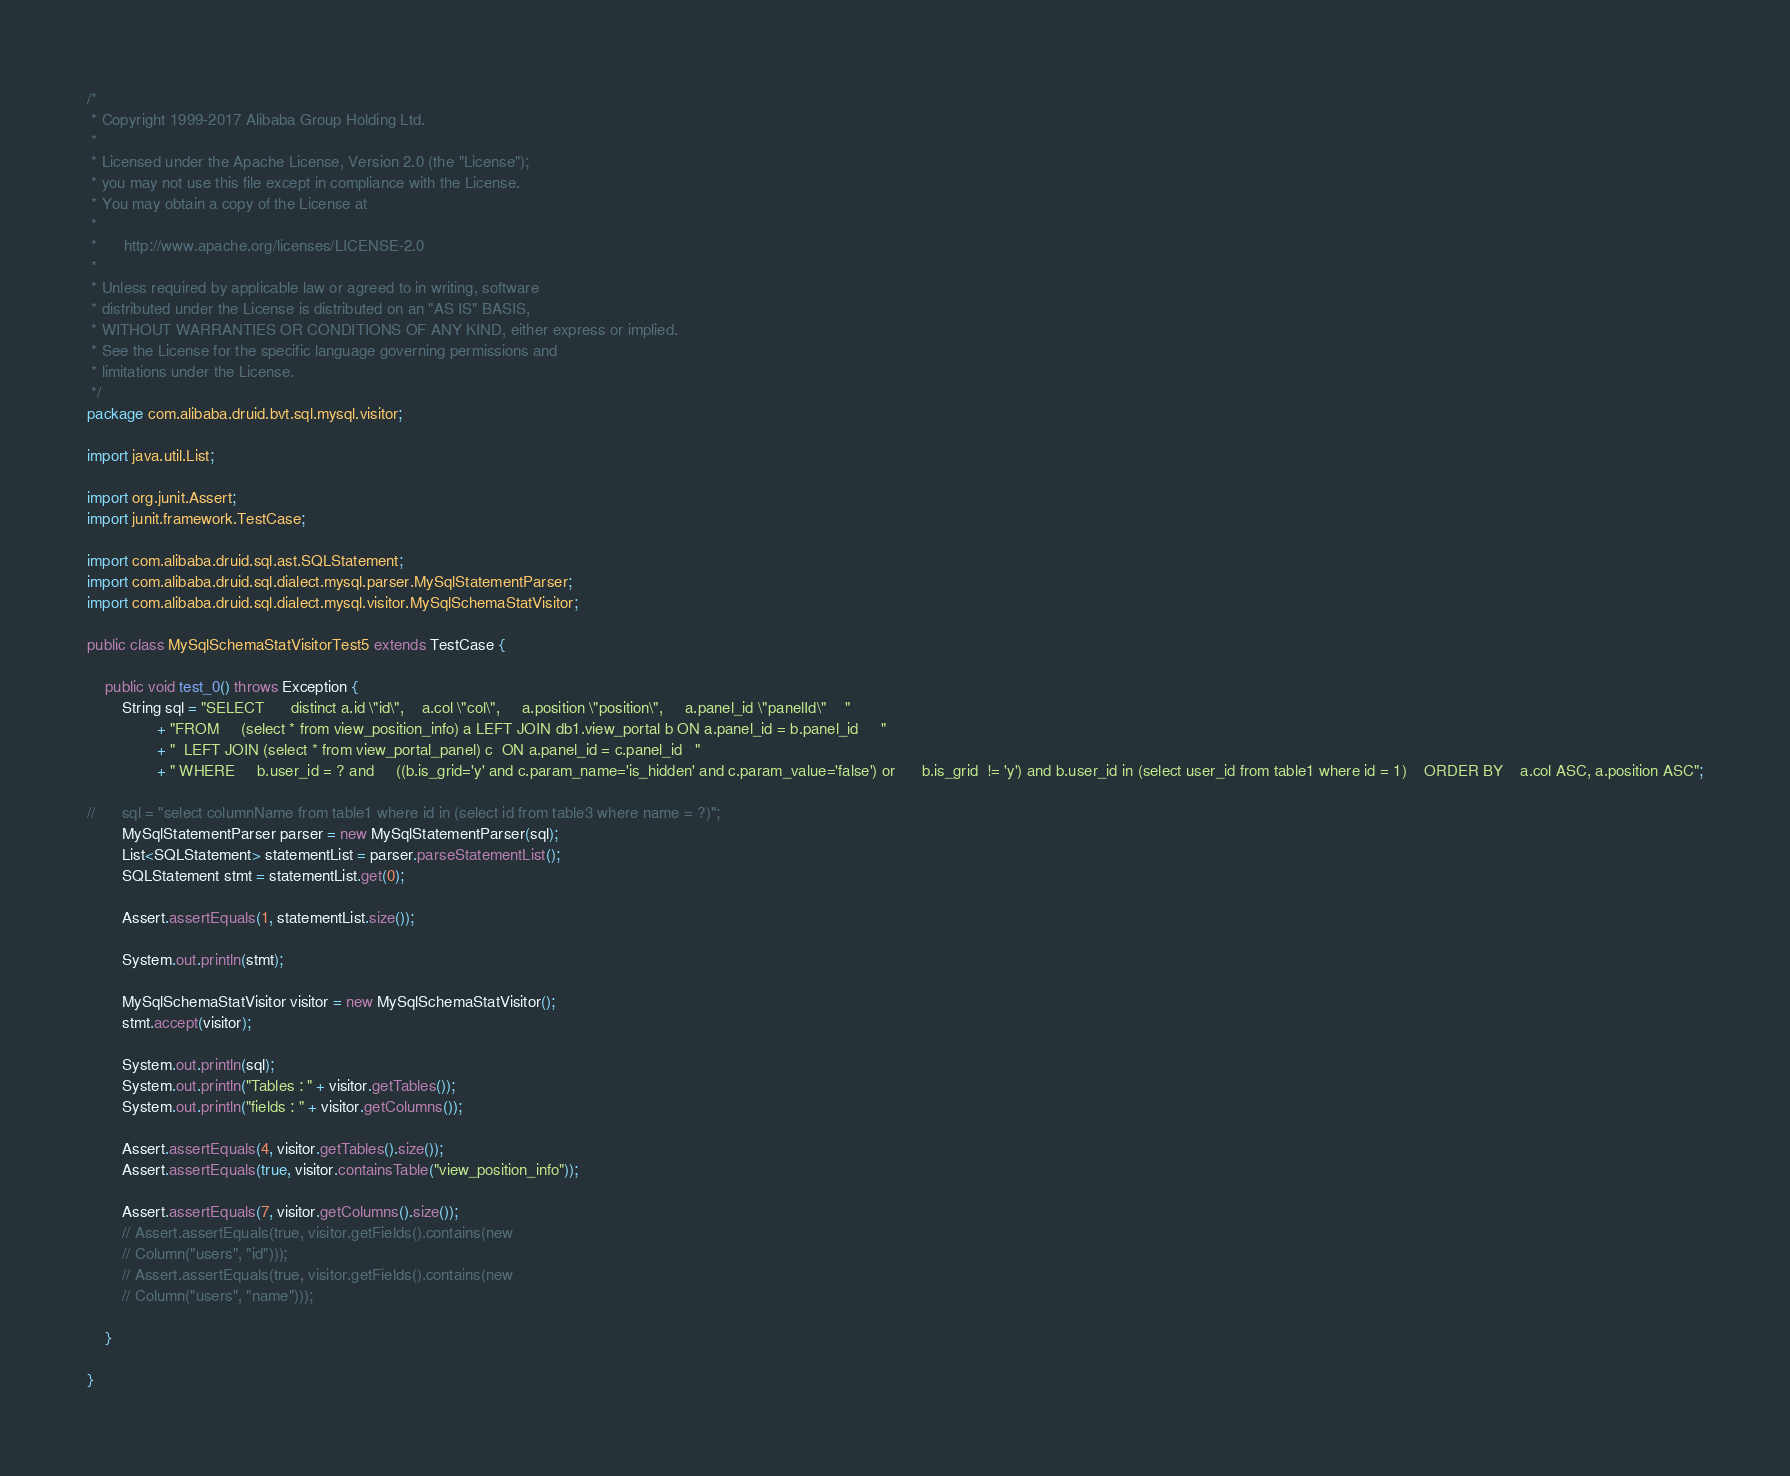<code> <loc_0><loc_0><loc_500><loc_500><_Java_>/*
 * Copyright 1999-2017 Alibaba Group Holding Ltd.
 *
 * Licensed under the Apache License, Version 2.0 (the "License");
 * you may not use this file except in compliance with the License.
 * You may obtain a copy of the License at
 *
 *      http://www.apache.org/licenses/LICENSE-2.0
 *
 * Unless required by applicable law or agreed to in writing, software
 * distributed under the License is distributed on an "AS IS" BASIS,
 * WITHOUT WARRANTIES OR CONDITIONS OF ANY KIND, either express or implied.
 * See the License for the specific language governing permissions and
 * limitations under the License.
 */
package com.alibaba.druid.bvt.sql.mysql.visitor;

import java.util.List;

import org.junit.Assert;
import junit.framework.TestCase;

import com.alibaba.druid.sql.ast.SQLStatement;
import com.alibaba.druid.sql.dialect.mysql.parser.MySqlStatementParser;
import com.alibaba.druid.sql.dialect.mysql.visitor.MySqlSchemaStatVisitor;

public class MySqlSchemaStatVisitorTest5 extends TestCase {

	public void test_0() throws Exception {
		String sql = "SELECT      distinct a.id \"id\",    a.col \"col\",     a.position \"position\",     a.panel_id \"panelId\"    "
				+ "FROM     (select * from view_position_info) a LEFT JOIN db1.view_portal b ON a.panel_id = b.panel_id     "
				+ "  LEFT JOIN (select * from view_portal_panel) c  ON a.panel_id = c.panel_id   "
				+ " WHERE     b.user_id = ? and     ((b.is_grid='y' and c.param_name='is_hidden' and c.param_value='false') or      b.is_grid  != 'y') and b.user_id in (select user_id from table1 where id = 1)    ORDER BY    a.col ASC, a.position ASC";

//		sql = "select columnName from table1 where id in (select id from table3 where name = ?)";
		MySqlStatementParser parser = new MySqlStatementParser(sql);
		List<SQLStatement> statementList = parser.parseStatementList();
		SQLStatement stmt = statementList.get(0);

		Assert.assertEquals(1, statementList.size());

		System.out.println(stmt);

		MySqlSchemaStatVisitor visitor = new MySqlSchemaStatVisitor();
		stmt.accept(visitor);

		System.out.println(sql);
		System.out.println("Tables : " + visitor.getTables());
		System.out.println("fields : " + visitor.getColumns());

		Assert.assertEquals(4, visitor.getTables().size());
		Assert.assertEquals(true, visitor.containsTable("view_position_info"));

		Assert.assertEquals(7, visitor.getColumns().size());
		// Assert.assertEquals(true, visitor.getFields().contains(new
		// Column("users", "id")));
		// Assert.assertEquals(true, visitor.getFields().contains(new
		// Column("users", "name")));

	}

}
</code> 